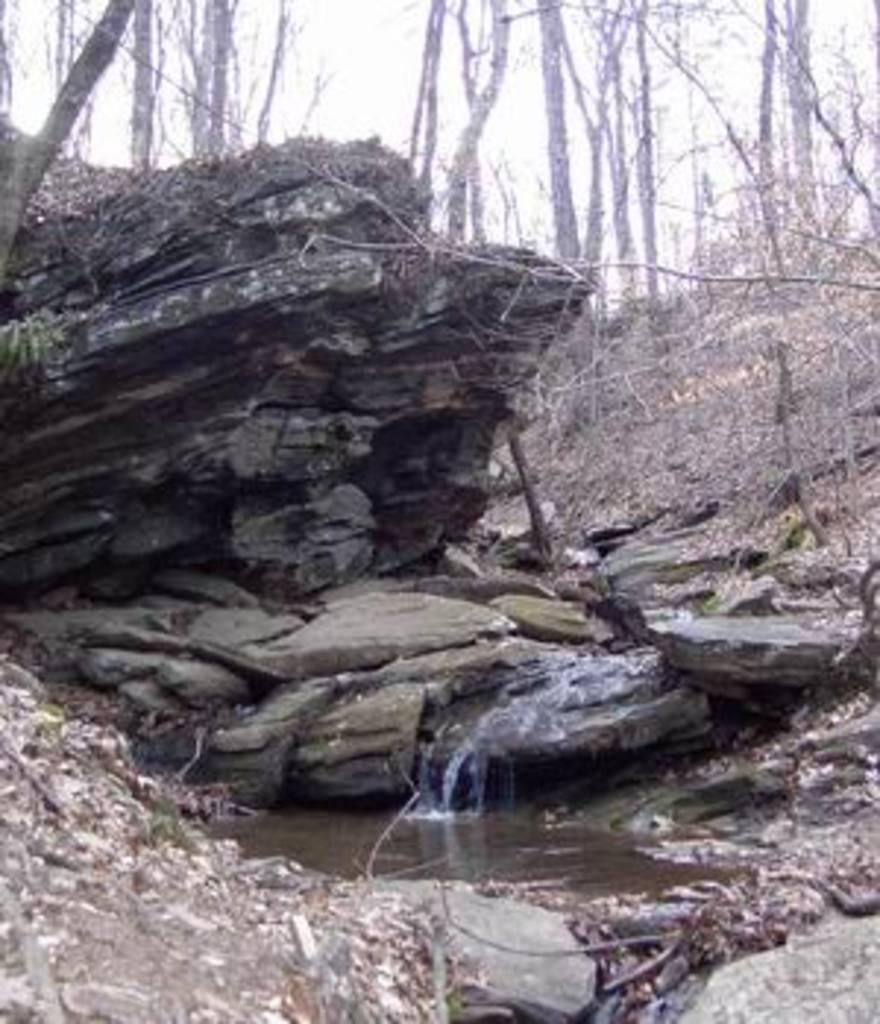What is present in the front of the image? There is water in the front of the image. What can be seen in the background of the image? There are stones and trees in the background of the image. What type of power is being generated by the trees in the image? There is no power generation mentioned or depicted in the image; it features water in the front and stones and trees in the background. How does the throat of the stone appear in the image? There is no mention of a throat or any living organism associated with the stones in the image. 